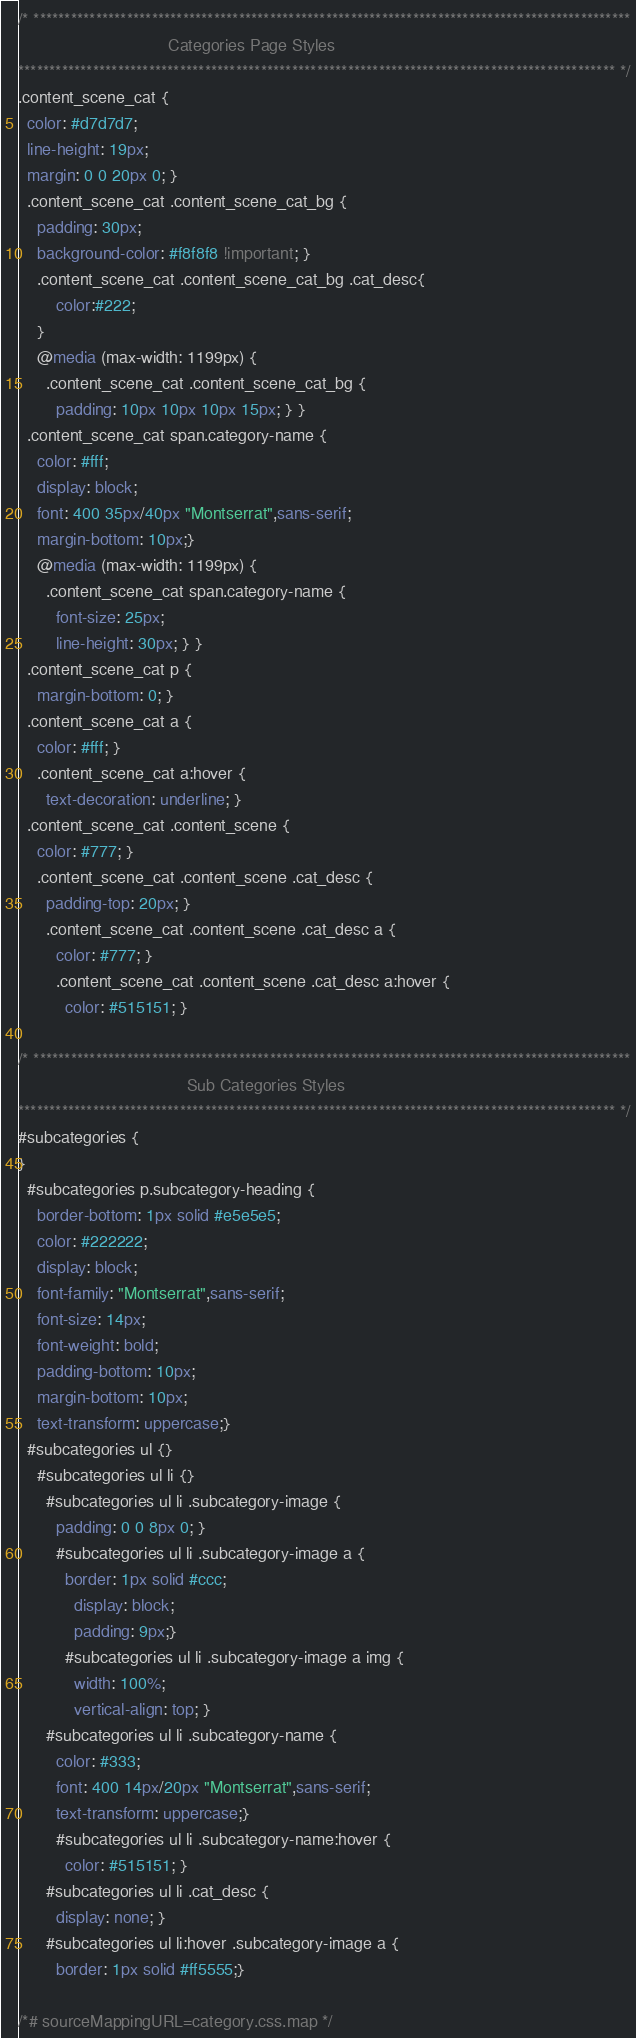Convert code to text. <code><loc_0><loc_0><loc_500><loc_500><_CSS_>/* ************************************************************************************************
								Categories Page Styles
************************************************************************************************ */
.content_scene_cat {
  color: #d7d7d7;
  line-height: 19px;
  margin: 0 0 20px 0; }
  .content_scene_cat .content_scene_cat_bg {
	padding: 30px;  
    background-color: #f8f8f8 !important; }
	.content_scene_cat .content_scene_cat_bg .cat_desc{
		color:#222;
	}
    @media (max-width: 1199px) {
      .content_scene_cat .content_scene_cat_bg {
        padding: 10px 10px 10px 15px; } }
  .content_scene_cat span.category-name {
    color: #fff;
    display: block;
    font: 400 35px/40px "Montserrat",sans-serif;
    margin-bottom: 10px;}
    @media (max-width: 1199px) {
      .content_scene_cat span.category-name {
        font-size: 25px;
        line-height: 30px; } }
  .content_scene_cat p {
    margin-bottom: 0; }
  .content_scene_cat a {
    color: #fff; }
    .content_scene_cat a:hover {
      text-decoration: underline; }
  .content_scene_cat .content_scene {
    color: #777; }
    .content_scene_cat .content_scene .cat_desc {
      padding-top: 20px; }
      .content_scene_cat .content_scene .cat_desc a {
        color: #777; }
        .content_scene_cat .content_scene .cat_desc a:hover {
          color: #515151; }

/* ************************************************************************************************
									Sub Categories Styles
************************************************************************************************ */
#subcategories {
}
  #subcategories p.subcategory-heading {
	border-bottom: 1px solid #e5e5e5;
    color: #222222;
    display: block;
    font-family: "Montserrat",sans-serif;
    font-size: 14px;
    font-weight: bold;
    padding-bottom: 10px;
    margin-bottom: 10px;
    text-transform: uppercase;}
  #subcategories ul {}
    #subcategories ul li {}
      #subcategories ul li .subcategory-image {
        padding: 0 0 8px 0; }
        #subcategories ul li .subcategory-image a {
          border: 1px solid #ccc;
			display: block;
			padding: 9px;}
          #subcategories ul li .subcategory-image a img {
            width: 100%;
            vertical-align: top; }
      #subcategories ul li .subcategory-name {
        color: #333;
		font: 400 14px/20px "Montserrat",sans-serif;
		text-transform: uppercase;}
        #subcategories ul li .subcategory-name:hover {
          color: #515151; }
      #subcategories ul li .cat_desc {
        display: none; }
      #subcategories ul li:hover .subcategory-image a {
        border: 1px solid #ff5555;}

/*# sourceMappingURL=category.css.map */
</code> 